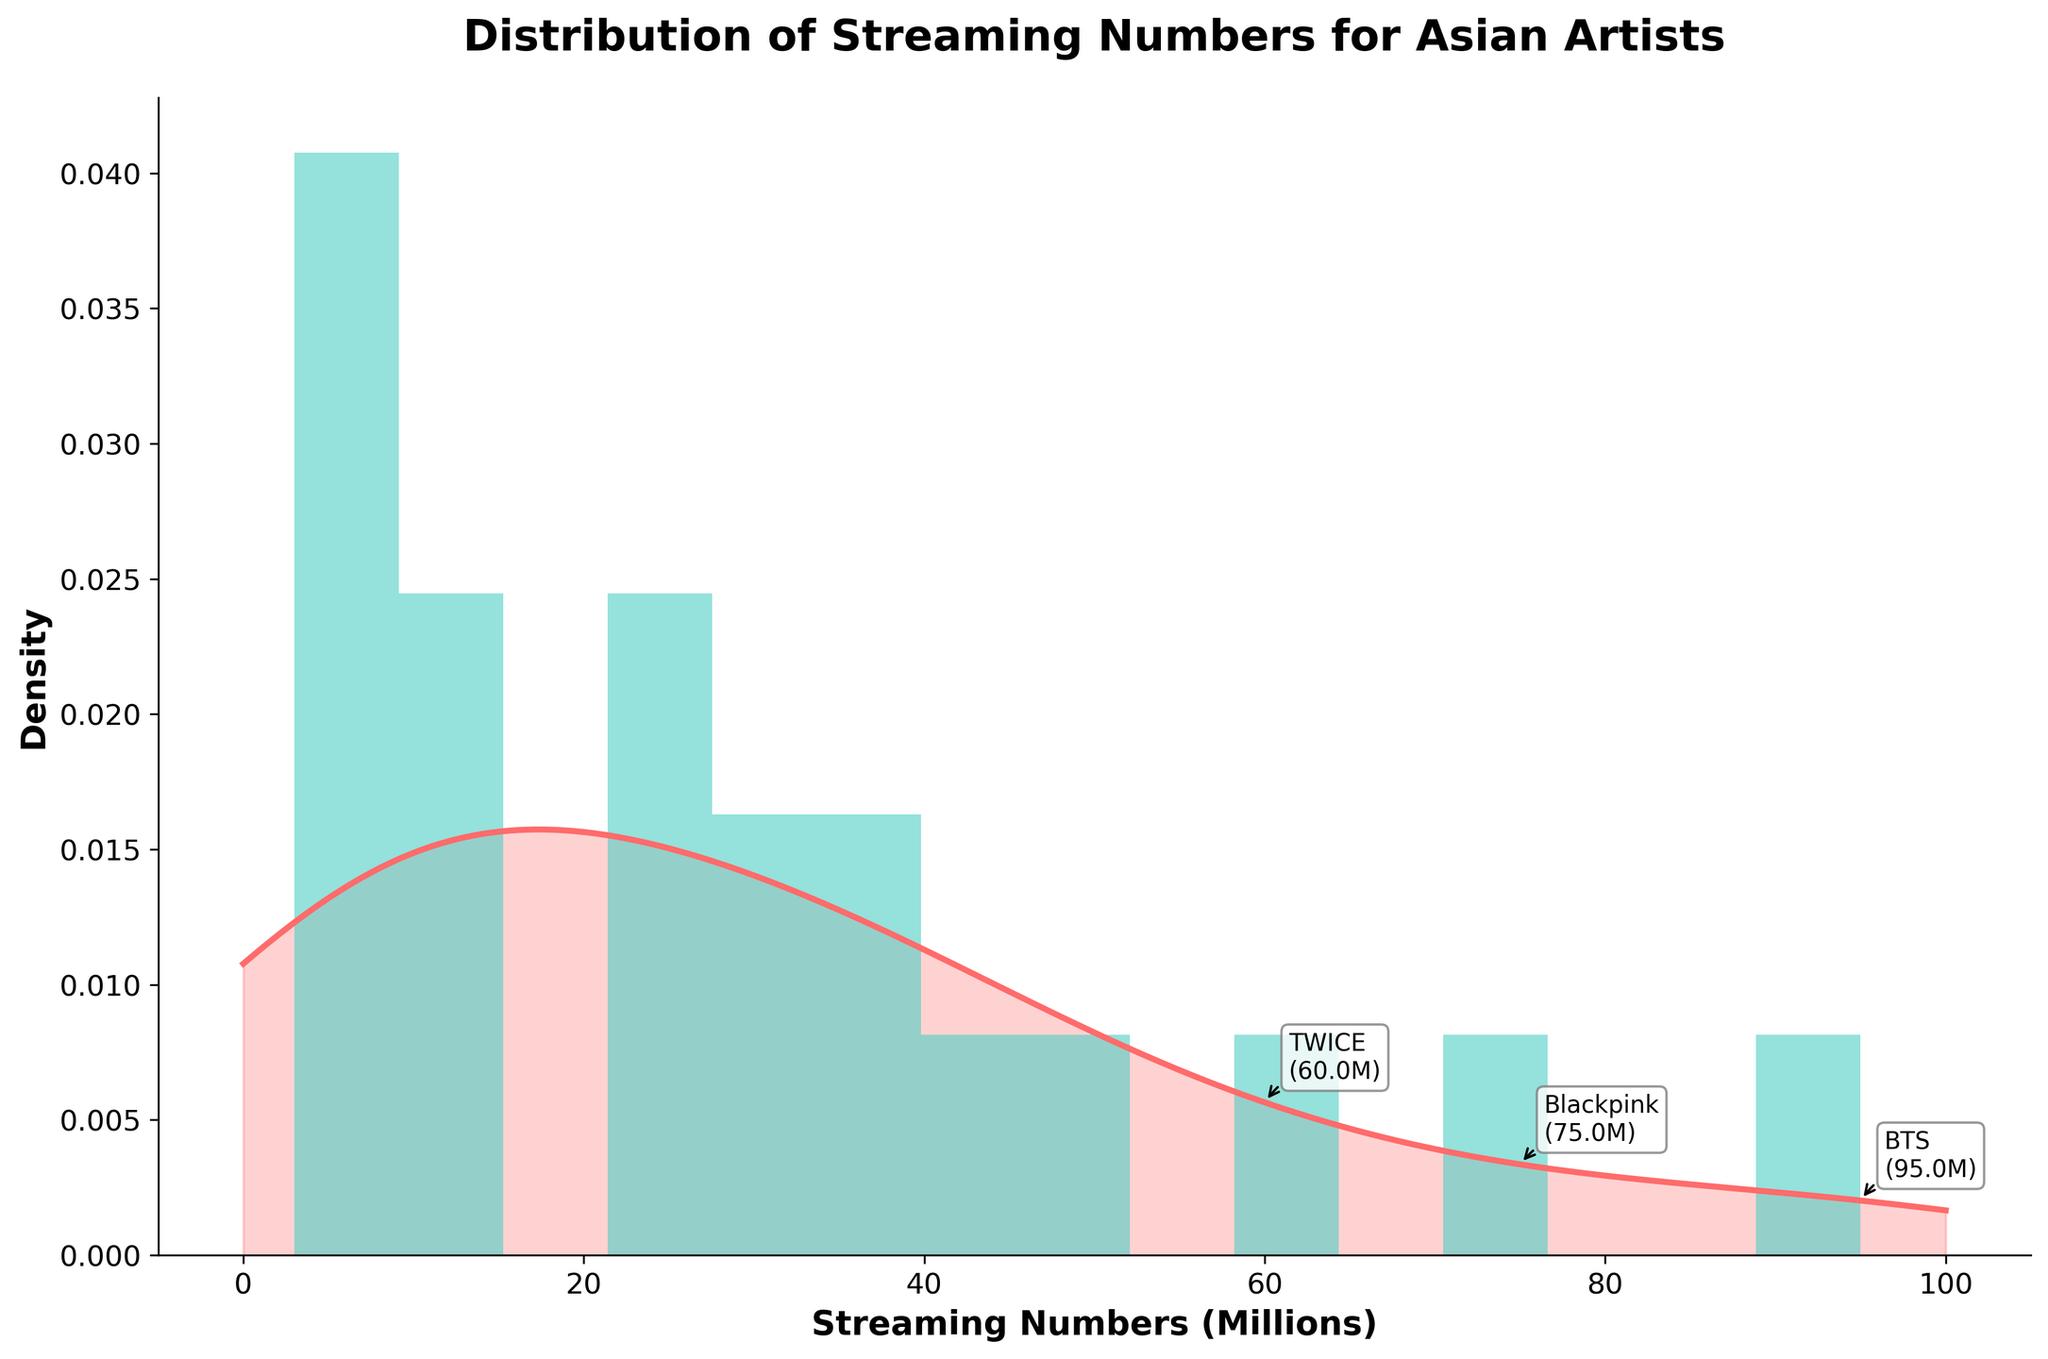what is the title of the figure? The title is written at the top of the figure and states the main insight the figure is depicting.
Answer: Distribution of Streaming Numbers for Asian Artists what data is displayed on the x-axis? The x-axis label shows the quantities being measured along this axis. It is labeled as streaming numbers in millions.
Answer: Streaming Numbers (Millions) how many artists have streams between 0 and 10 million? By looking at the height of the histogram bars between 0 and 10 million on the x-axis, count the number of artists. There are peaks showing artists with 3M, 5M, 7M, and 10M streams.
Answer: Four artists which artist has the highest streaming numbers? The plot includes text annotations for the top artists. The one with the largest annotation is the artist with the highest streaming numbers.
Answer: BTS what is the range of the artists' streaming numbers shown in the plot? The x-axis range provides minimum and maximum values. It starts from 0 million up to 100 million streaming numbers.
Answer: 0 to 100 million how many top artists are annotated in the plot? Text annotations on the plot indicate the top artists. Count these annotations. There are three annotations displayed for the top artists.
Answer: Three which artist has the lowest streaming numbers and what is the count? The histogram bar on the far left indicates the lowest range of streaming numbers. The label of the bar indicates the count.
Answer: Hikaru Utada, 3 million which color represents the histogram and which color represents the KDE in the plot? The histogram is filled with a color different from the line representing the KDE. Identify the colors based on the visual appearance. The histogram is in teal, and the KDE is in reddish color.
Answer: Histogram: Teal, KDE: Reddish what is the general trend observed in the KDE line? Examine the KDE line's shape to understand the distribution. The KDE line shows the density of data at different streaming numbers.
Answer: The KDE line peaks at around 10-15 million and decreases gradually what streaming number range has the highest density according to the KDE line? The peak of the KDE line represents the range with the highest density of streaming numbers. Look at the x-axis value corresponding to this peak.
Answer: Around 10-15 million 